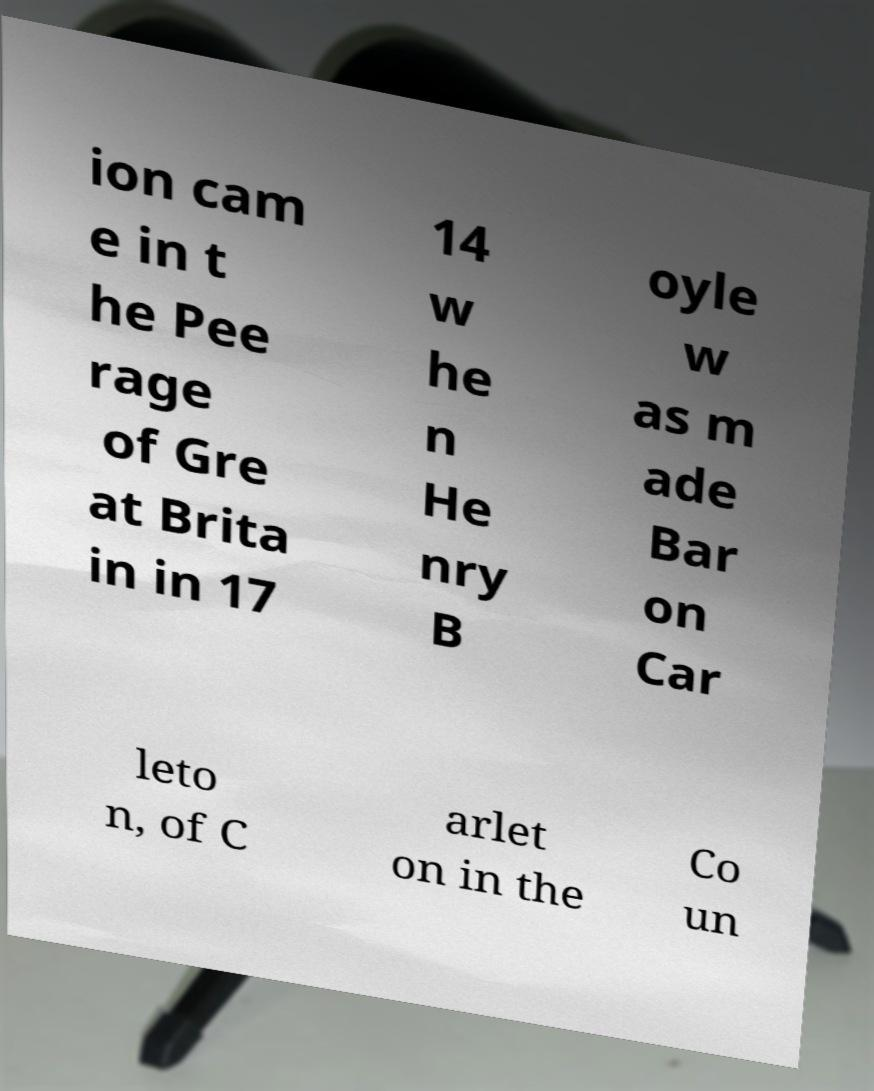Please read and relay the text visible in this image. What does it say? ion cam e in t he Pee rage of Gre at Brita in in 17 14 w he n He nry B oyle w as m ade Bar on Car leto n, of C arlet on in the Co un 